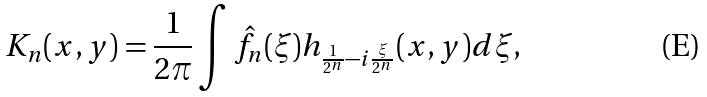<formula> <loc_0><loc_0><loc_500><loc_500>K _ { n } ( x , y ) = \frac { 1 } { 2 \pi } \int \hat { f } _ { n } ( \xi ) h _ { \frac { 1 } { 2 ^ { n } } - i \frac { \xi } { 2 ^ { n } } } ( x , y ) d \xi ,</formula> 